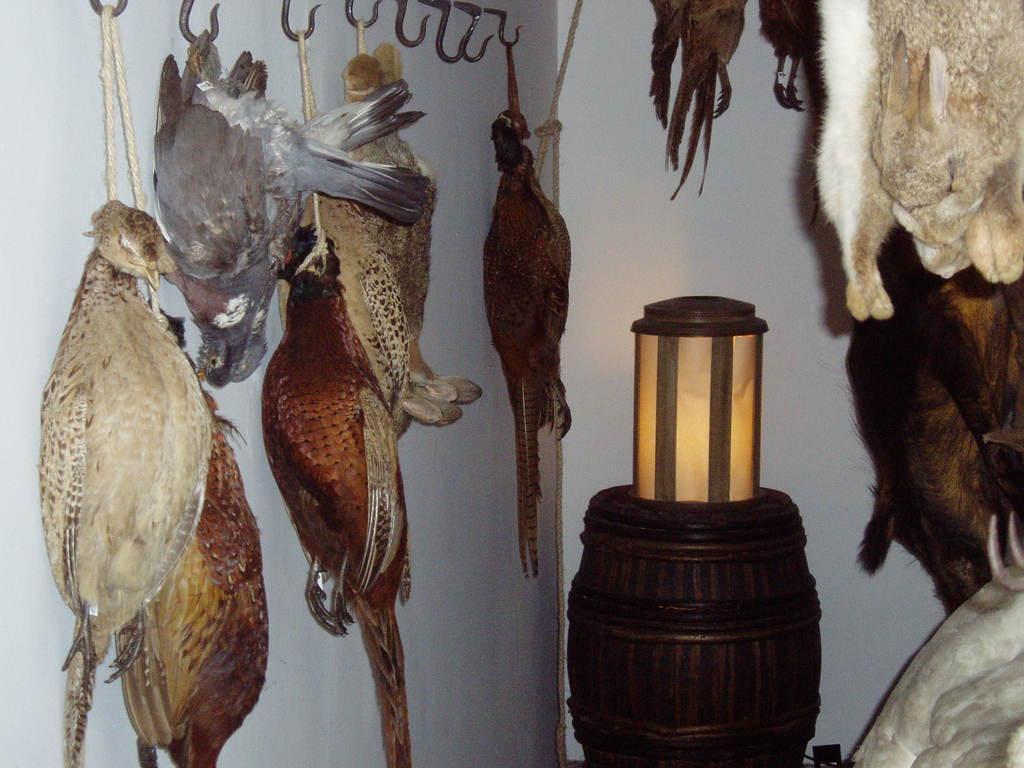Can you describe this image briefly? In the picture I can see the birds hung to the hook stand on the left side. I can see a wooden drum and there is a lamp on it. I can see the animals hung on the right side. 